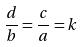Convert formula to latex. <formula><loc_0><loc_0><loc_500><loc_500>\frac { d } { b } = \frac { c } { a } = k</formula> 